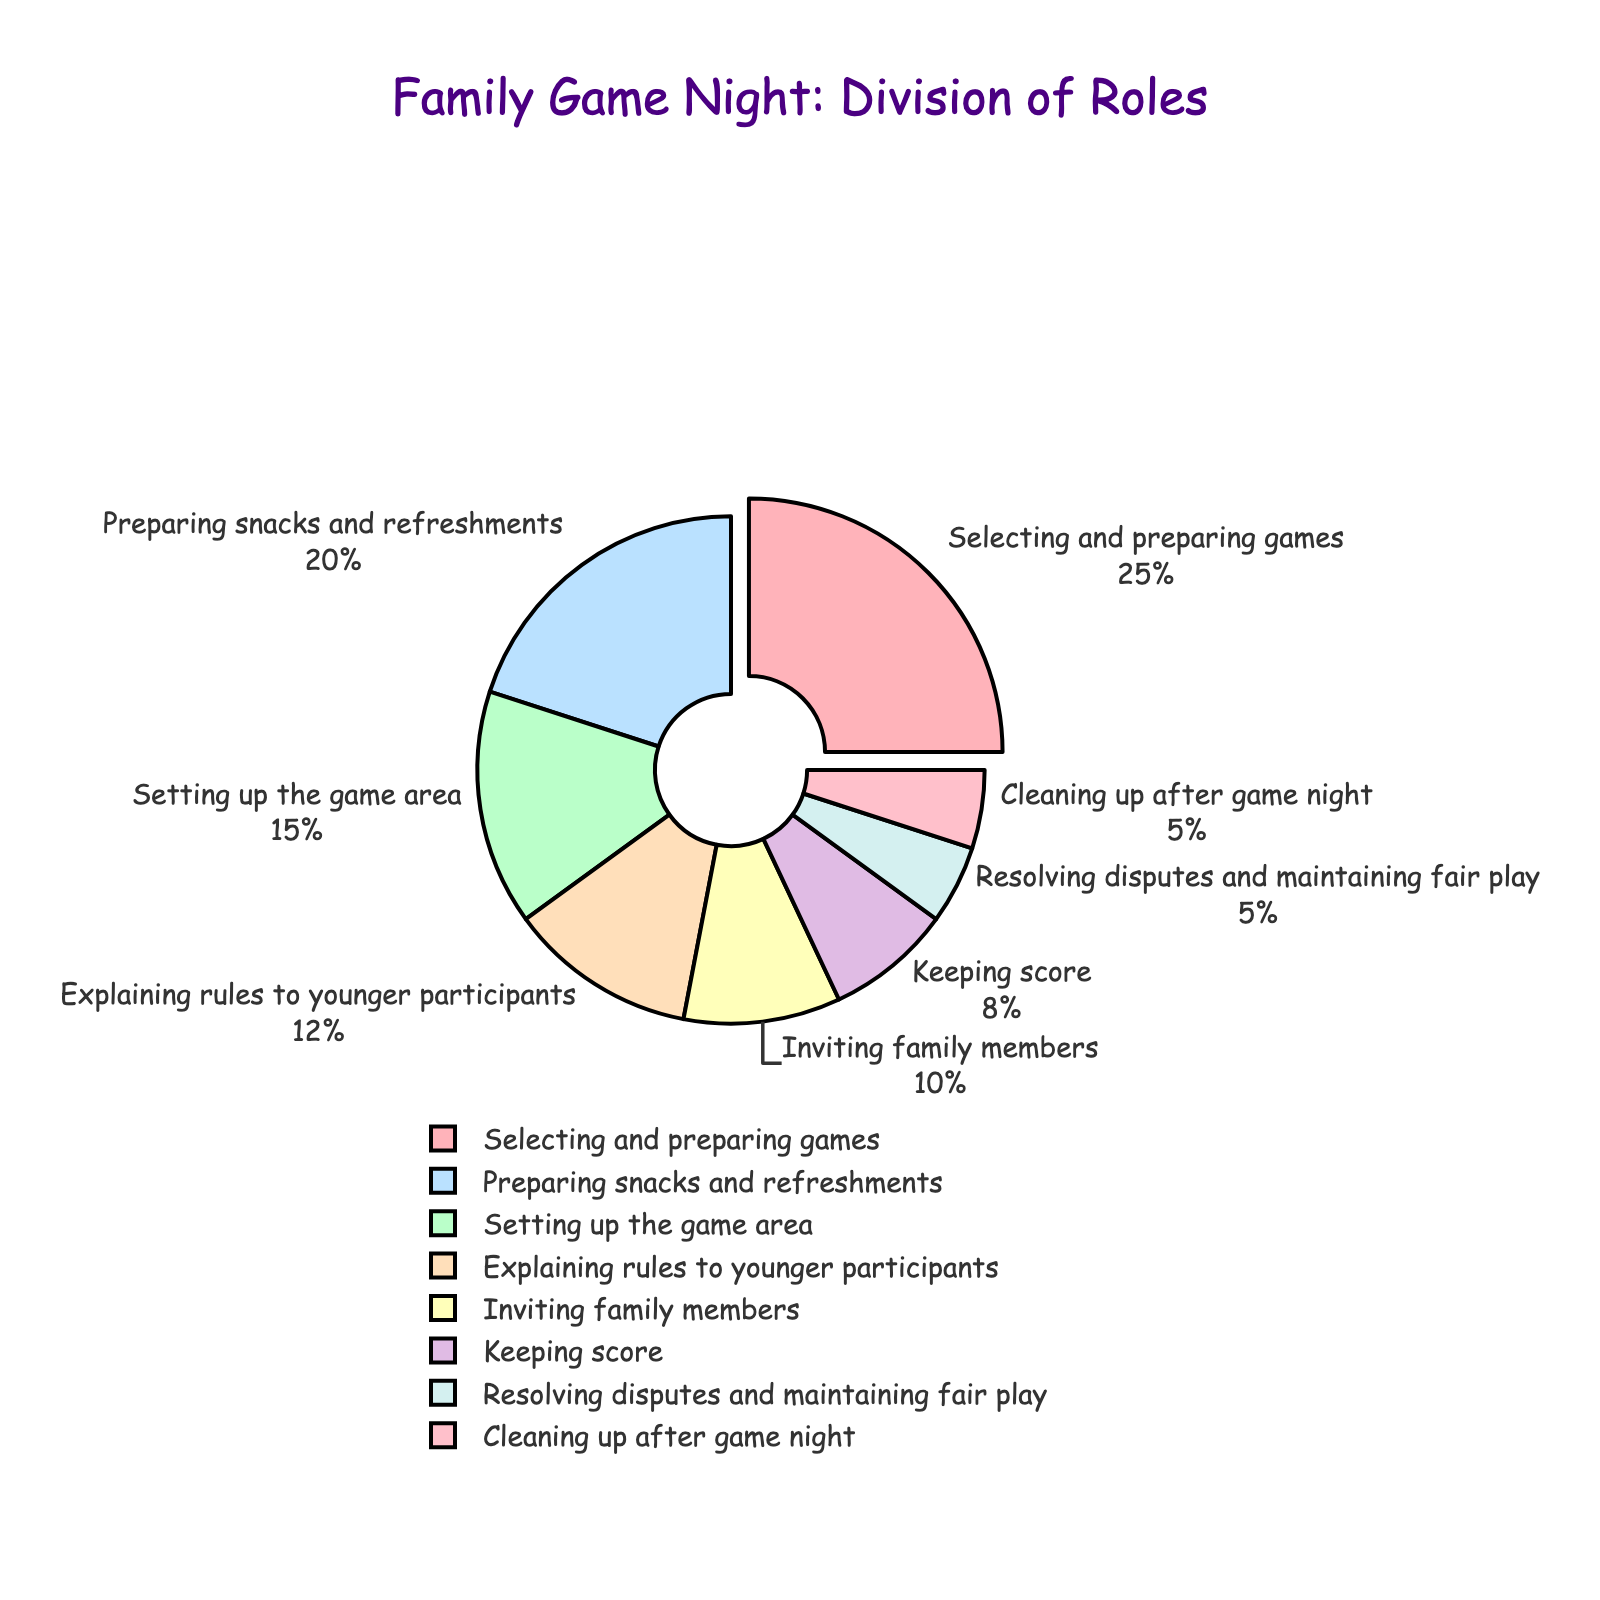How many roles have a responsibility percentage greater than 10%? We need to count the roles with percentages higher than 10. These roles are "Selecting and preparing games" (25%), "Setting up the game area" (15%), "Preparing snacks and refreshments" (20%), and "Explaining rules to younger participants" (12%). There are 4 roles in total.
Answer: 4 Which role has the smallest responsibility percentage? We need to identify the role with the smallest percentage. Both "Resolving disputes and maintaining fair play" and "Cleaning up after game night" have the smallest percentage at 5%.
Answer: Resolving disputes and maintaining fair play, Cleaning up after game night Is the total percentage for "Selecting and preparing games" and "Preparing snacks and refreshments" greater than 40%? Adding the percentages of these two roles: 25% (Selecting and preparing games) + 20% (Preparing snacks and refreshments) = 45%. Since 45% is greater than 40%, the answer is yes.
Answer: Yes Which role has the largest responsibility percentage, and what is it? The largest percentage is for "Selecting and preparing games" at 25%.
Answer: Selecting and preparing games, 25% What is the difference in responsibility percentage between "Setting up the game area" and "Keeping score"? "Setting up the game area" has 15% responsibility and "Keeping score" has 8%. The difference is 15% - 8% = 7%.
Answer: 7% How many roles share an equal responsibility percentage? Both "Resolving disputes and maintaining fair play" and "Cleaning up after game night" have an equal responsibility percentage of 5%.
Answer: 2 Which role's slice of the pie chart is highlighted or slightly separated from the rest? The slice for "Selecting and preparing games" appears to be highlighted or slightly pulled out from the rest of the pie chart. This can be inferred as it has the highest percentage and is typically highlighted in such visualizations.
Answer: Selecting and preparing games What is the combined percentage of responsibilities for explaining rules to younger participants and keeping score? Adding the percentages for these two roles: 12% (Explaining rules to younger participants) + 8% (Keeping score) = 20%.
Answer: 20% 